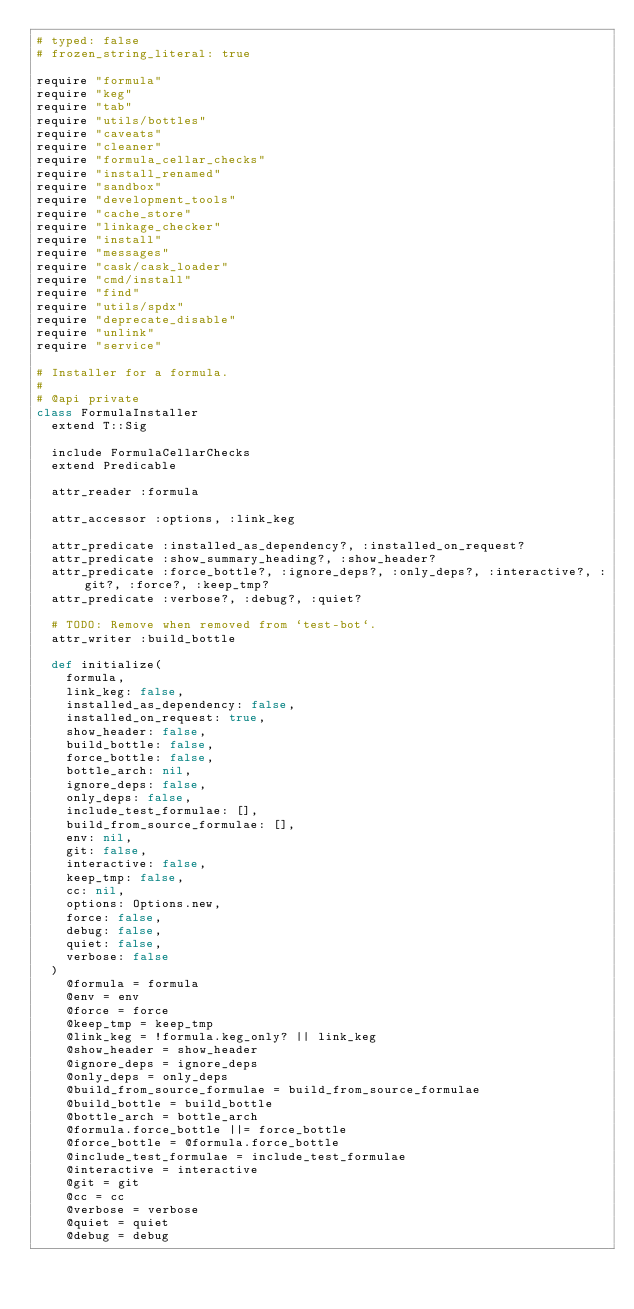Convert code to text. <code><loc_0><loc_0><loc_500><loc_500><_Ruby_># typed: false
# frozen_string_literal: true

require "formula"
require "keg"
require "tab"
require "utils/bottles"
require "caveats"
require "cleaner"
require "formula_cellar_checks"
require "install_renamed"
require "sandbox"
require "development_tools"
require "cache_store"
require "linkage_checker"
require "install"
require "messages"
require "cask/cask_loader"
require "cmd/install"
require "find"
require "utils/spdx"
require "deprecate_disable"
require "unlink"
require "service"

# Installer for a formula.
#
# @api private
class FormulaInstaller
  extend T::Sig

  include FormulaCellarChecks
  extend Predicable

  attr_reader :formula

  attr_accessor :options, :link_keg

  attr_predicate :installed_as_dependency?, :installed_on_request?
  attr_predicate :show_summary_heading?, :show_header?
  attr_predicate :force_bottle?, :ignore_deps?, :only_deps?, :interactive?, :git?, :force?, :keep_tmp?
  attr_predicate :verbose?, :debug?, :quiet?

  # TODO: Remove when removed from `test-bot`.
  attr_writer :build_bottle

  def initialize(
    formula,
    link_keg: false,
    installed_as_dependency: false,
    installed_on_request: true,
    show_header: false,
    build_bottle: false,
    force_bottle: false,
    bottle_arch: nil,
    ignore_deps: false,
    only_deps: false,
    include_test_formulae: [],
    build_from_source_formulae: [],
    env: nil,
    git: false,
    interactive: false,
    keep_tmp: false,
    cc: nil,
    options: Options.new,
    force: false,
    debug: false,
    quiet: false,
    verbose: false
  )
    @formula = formula
    @env = env
    @force = force
    @keep_tmp = keep_tmp
    @link_keg = !formula.keg_only? || link_keg
    @show_header = show_header
    @ignore_deps = ignore_deps
    @only_deps = only_deps
    @build_from_source_formulae = build_from_source_formulae
    @build_bottle = build_bottle
    @bottle_arch = bottle_arch
    @formula.force_bottle ||= force_bottle
    @force_bottle = @formula.force_bottle
    @include_test_formulae = include_test_formulae
    @interactive = interactive
    @git = git
    @cc = cc
    @verbose = verbose
    @quiet = quiet
    @debug = debug</code> 